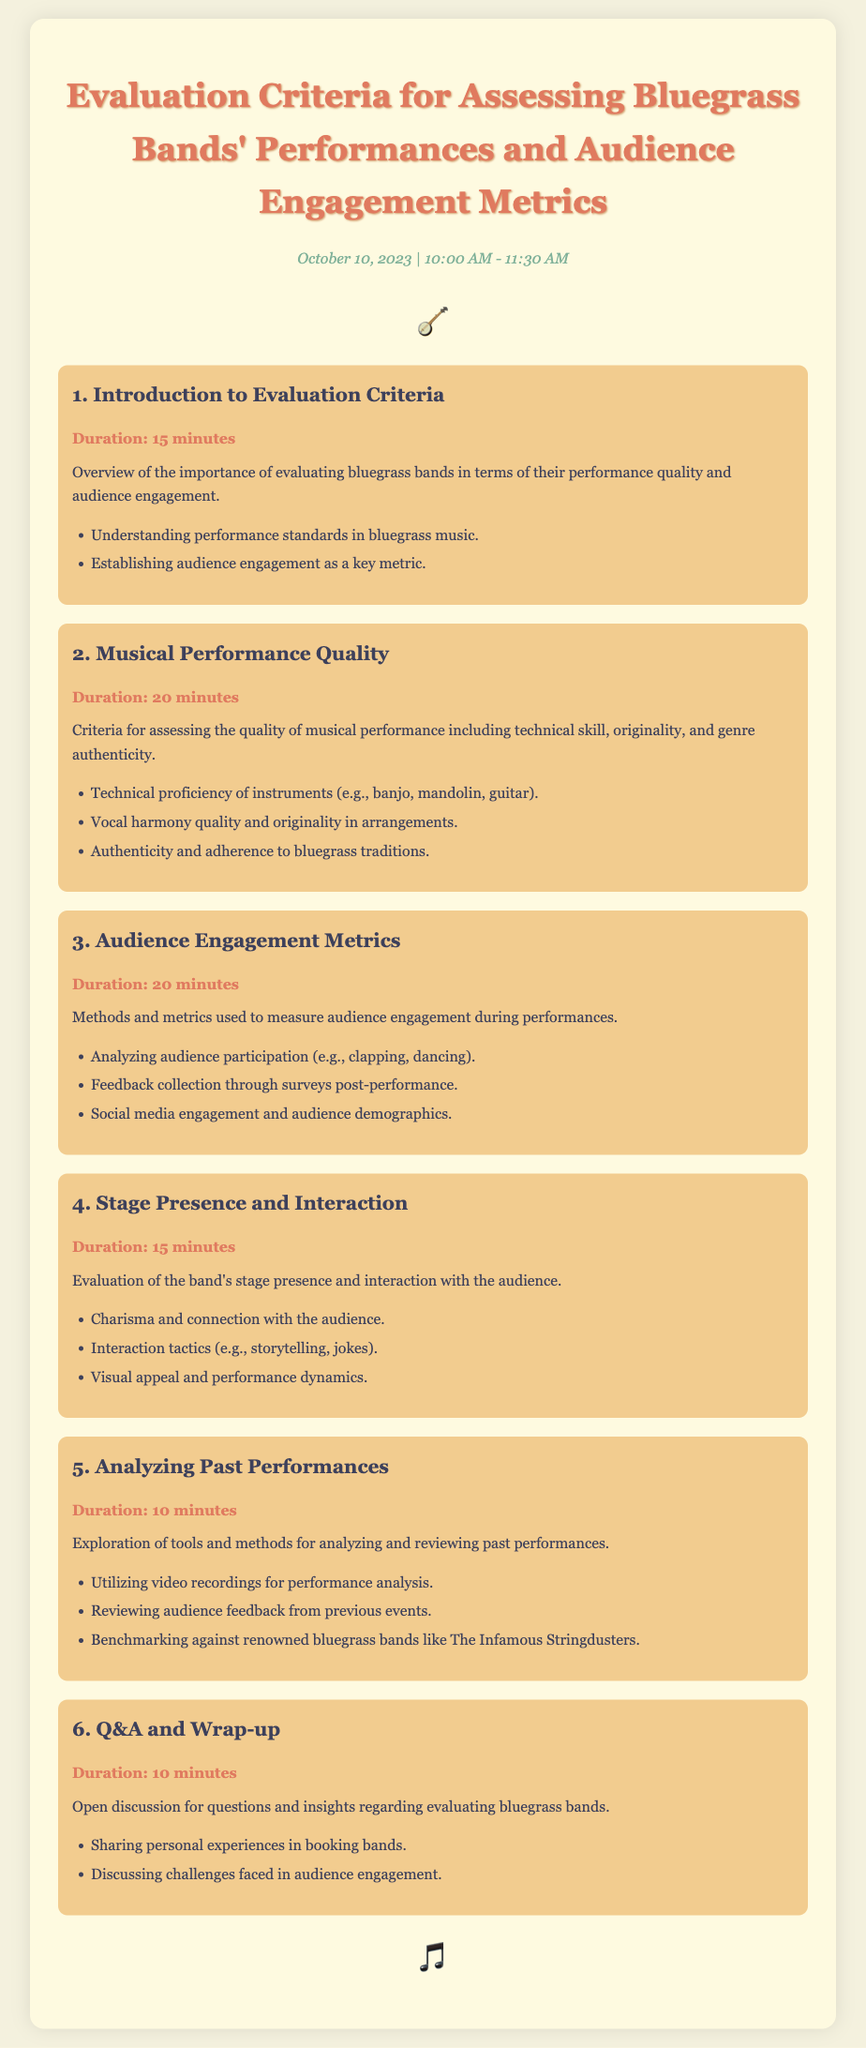What is the date of the evaluation agenda? The date appears prominently at the top of the document, indicating when the event will take place.
Answer: October 10, 2023 How long is the session on Musical Performance Quality? Each session has a specified duration, and this session's duration is mentioned under its title.
Answer: 20 minutes What is one aspect of audience engagement metrics discussed in the agenda? The document lists specific methods under the audience engagement section that measure audience participation.
Answer: Feedback collection What is the title of the final session in the agenda? Each session is clearly labeled, and the final one's title is presented in bold within the structure.
Answer: Q&A and Wrap-up What is one criterion for assessing Musical Performance Quality? The document gives specific criteria points under each session, highlighting crucial aspects of performance quality.
Answer: Technical proficiency of instruments How many total minutes are allocated for audience engagement discussions? By adding the durations of the relevant sessions, we can determine the total time dedicated to this topic.
Answer: 20 minutes In which section is stage presence evaluated? The document organizes sections, with the specific focus on stage presence indicated clearly within one of them.
Answer: Stage Presence and Interaction Which renowned bluegrass band is mentioned as a benchmark for analyzing past performances? The document references notable bands in context to performance evaluation as part of its content.
Answer: The Infamous Stringdusters 